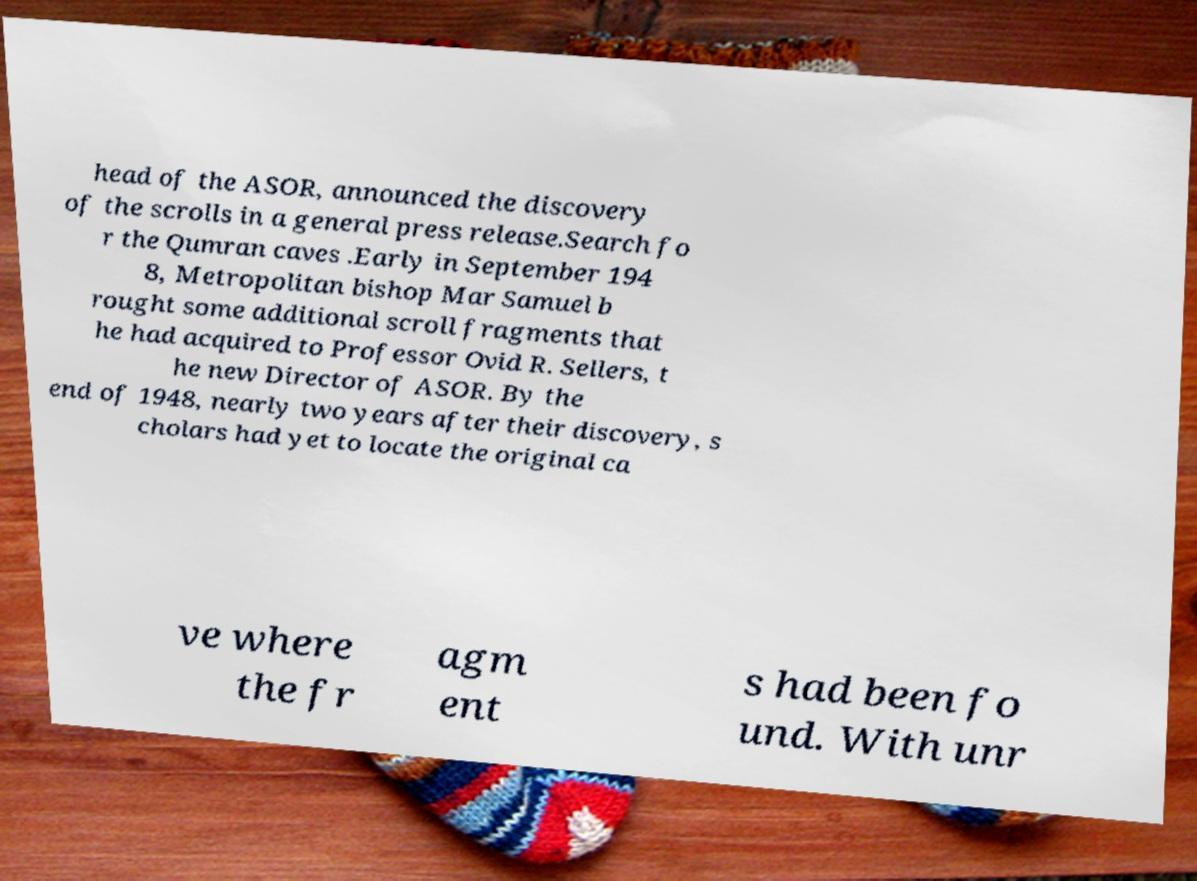Can you read and provide the text displayed in the image?This photo seems to have some interesting text. Can you extract and type it out for me? head of the ASOR, announced the discovery of the scrolls in a general press release.Search fo r the Qumran caves .Early in September 194 8, Metropolitan bishop Mar Samuel b rought some additional scroll fragments that he had acquired to Professor Ovid R. Sellers, t he new Director of ASOR. By the end of 1948, nearly two years after their discovery, s cholars had yet to locate the original ca ve where the fr agm ent s had been fo und. With unr 